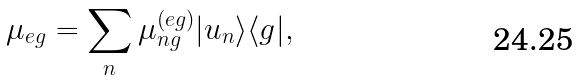<formula> <loc_0><loc_0><loc_500><loc_500>\mu _ { e g } = \sum _ { n } \mu _ { n g } ^ { ( e g ) } | u _ { n } \rangle \langle g | ,</formula> 